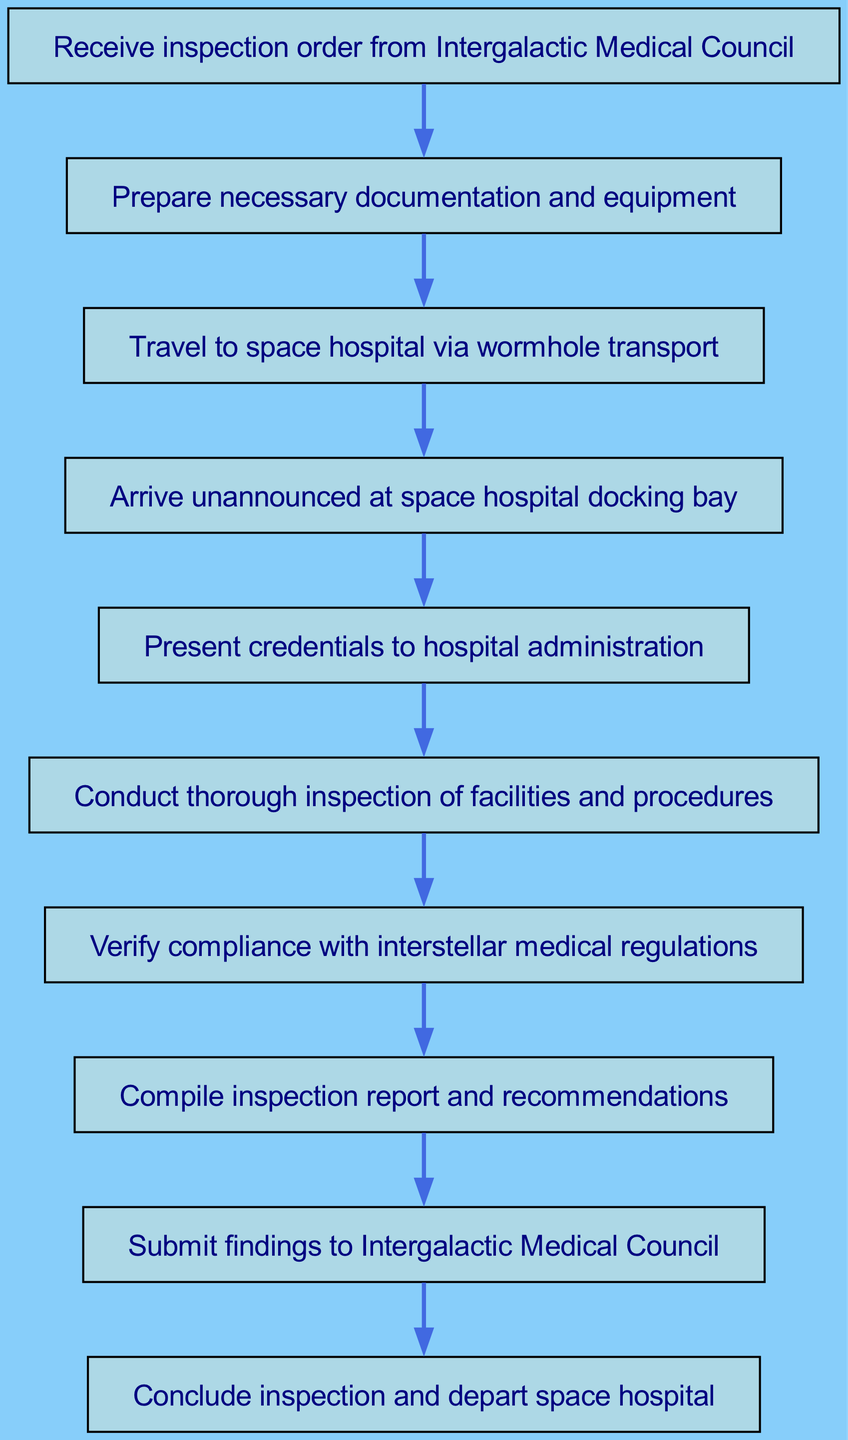What is the first step in the inspection process? The first step in the process, as indicated by the starting node, is to "Receive inspection order from Intergalactic Medical Council."
Answer: Receive inspection order from Intergalactic Medical Council How many nodes are present in the diagram? In the diagram, there are ten elements, each representing a specific step in the inspection process, counted from the starting point to the end.
Answer: Ten What action follows after traveling to the space hospital? According to the flow of the diagram, after the action of "Travel to space hospital via wormhole transport," the next action is "Arrive unannounced at space hospital docking bay."
Answer: Arrive unannounced at space hospital docking bay Which node immediately follows the "Verify compliance with interstellar medical regulations" node? The diagram specifies that the next step after "Verify compliance with interstellar medical regulations" is to "Compile inspection report and recommendations."
Answer: Compile inspection report and recommendations What is the last action taken at the end of the inspection? The concluding action of the inspection, as indicated at the termination of the flow, is to "Conclude inspection and depart space hospital."
Answer: Conclude inspection and depart space hospital Which two steps are connected by an edge directly in the diagram? By analyzing the edges in the diagram, the steps "Inspect" and "Verify compliance with interstellar medical regulations" are directly connected, reflecting the sequence of tasks during the inspection.
Answer: Inspect and Verify compliance with interstellar medical regulations What documentation is prepared before traveling? Before the traveling step in the process, the documentation referenced is "Prepare necessary documentation and equipment."
Answer: Prepare necessary documentation and equipment What is the total number of connections in the diagram? The total number of connections can be determined by counting the directed edges that link each step to the next, which amounts to nine connections in total.
Answer: Nine 